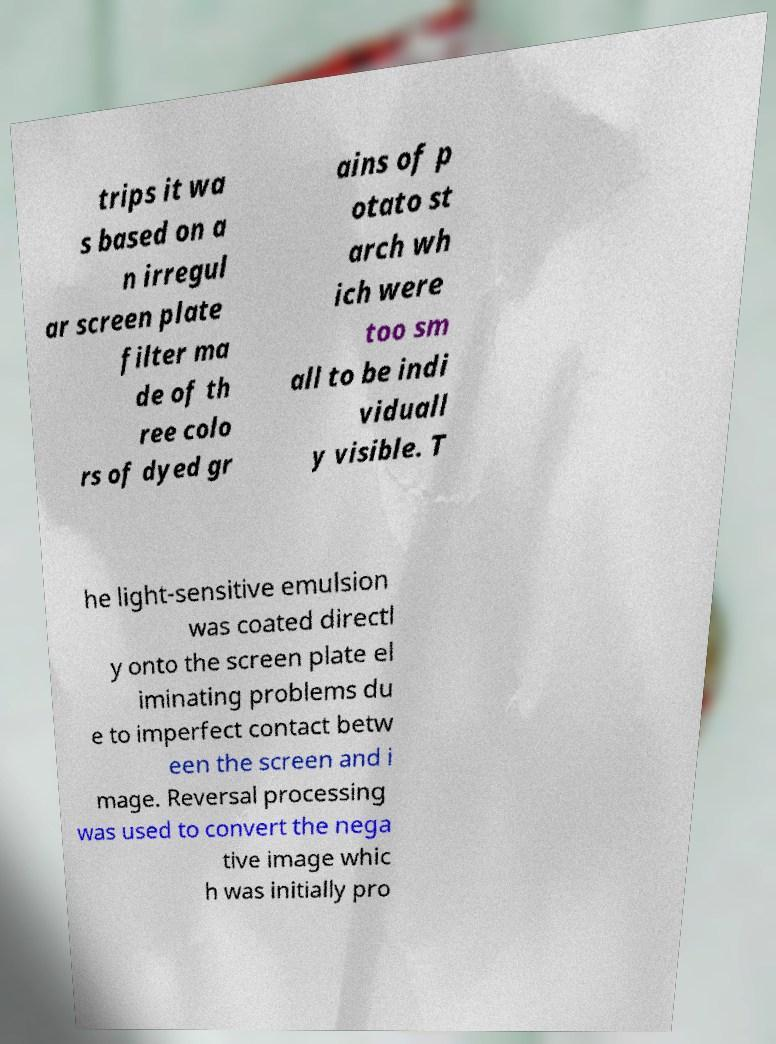Could you extract and type out the text from this image? trips it wa s based on a n irregul ar screen plate filter ma de of th ree colo rs of dyed gr ains of p otato st arch wh ich were too sm all to be indi viduall y visible. T he light-sensitive emulsion was coated directl y onto the screen plate el iminating problems du e to imperfect contact betw een the screen and i mage. Reversal processing was used to convert the nega tive image whic h was initially pro 